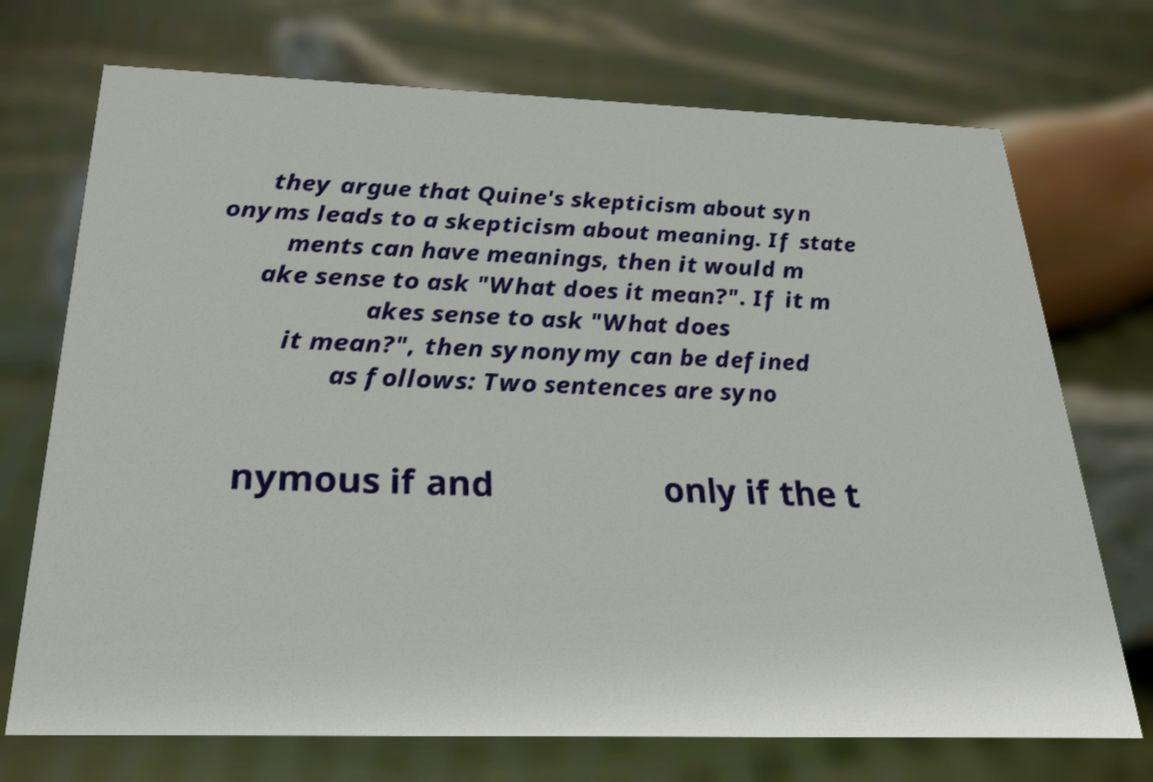Could you assist in decoding the text presented in this image and type it out clearly? they argue that Quine's skepticism about syn onyms leads to a skepticism about meaning. If state ments can have meanings, then it would m ake sense to ask "What does it mean?". If it m akes sense to ask "What does it mean?", then synonymy can be defined as follows: Two sentences are syno nymous if and only if the t 